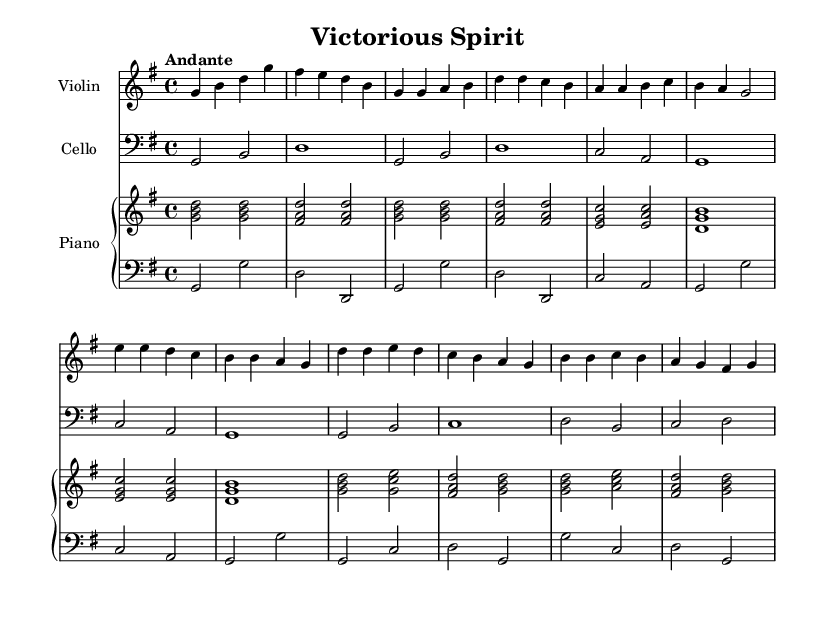What is the key signature of this music? The key signature shows one sharp on the staff, which indicates that the key is G major.
Answer: G major What is the time signature of this music? The time signature is indicated at the beginning of the piece, and it shows four beats per measure, which is denoted by 4/4.
Answer: 4/4 What is the tempo marking? The tempo marking says "Andante," which indicates a moderate pace.
Answer: Andante How many measures are in the chorus section? By counting the measures included in the chorus part of the sheet music, it is observed that there are four measures in total.
Answer: Four What instrument is featured alongside the violin? Looking at the score, the second staff explicitly mentions "Cello," indicating this instrument's presence in the piece.
Answer: Cello What is the first chord played by the piano? The first chord is indicated at the beginning of the sheet music, which shows the notes G, B, and D played together, representing a G major chord.
Answer: G major What is the structure of the piece based on its sections? The piece is structured into an Intro, Verse, Bridge, and Chorus, as laid out in the music. This hierarchical structure is common in many inspirational and religious compositions.
Answer: Intro, Verse, Bridge, Chorus 